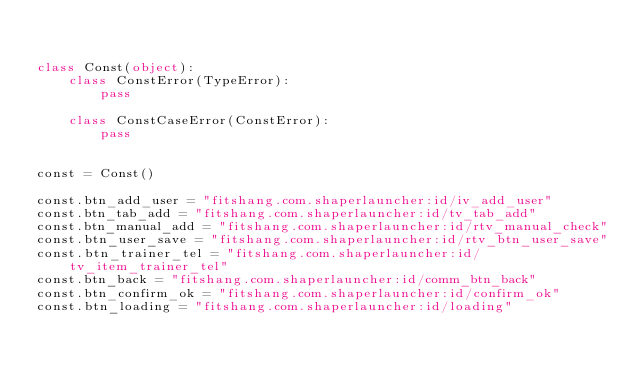<code> <loc_0><loc_0><loc_500><loc_500><_Python_>

class Const(object):
    class ConstError(TypeError):
        pass

    class ConstCaseError(ConstError):
        pass


const = Const()

const.btn_add_user = "fitshang.com.shaperlauncher:id/iv_add_user"
const.btn_tab_add = "fitshang.com.shaperlauncher:id/tv_tab_add"
const.btn_manual_add = "fitshang.com.shaperlauncher:id/rtv_manual_check"
const.btn_user_save = "fitshang.com.shaperlauncher:id/rtv_btn_user_save"
const.btn_trainer_tel = "fitshang.com.shaperlauncher:id/tv_item_trainer_tel"
const.btn_back = "fitshang.com.shaperlauncher:id/comm_btn_back"
const.btn_confirm_ok = "fitshang.com.shaperlauncher:id/confirm_ok"
const.btn_loading = "fitshang.com.shaperlauncher:id/loading"</code> 